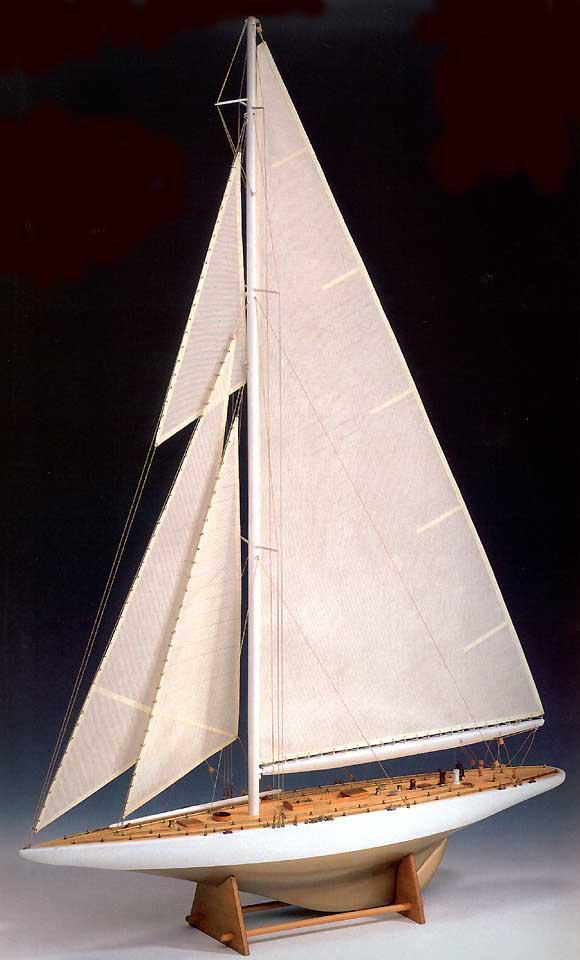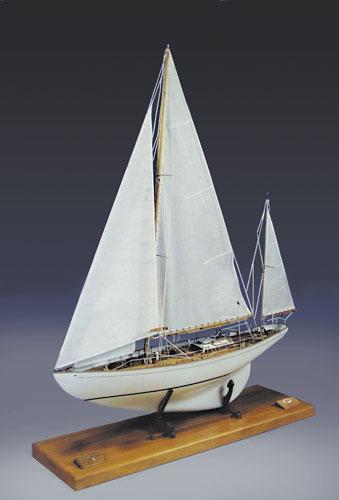The first image is the image on the left, the second image is the image on the right. Considering the images on both sides, is "The boats in the image on the left are in the water." valid? Answer yes or no. No. The first image is the image on the left, the second image is the image on the right. Analyze the images presented: Is the assertion "All sailing ships are floating on water." valid? Answer yes or no. No. 